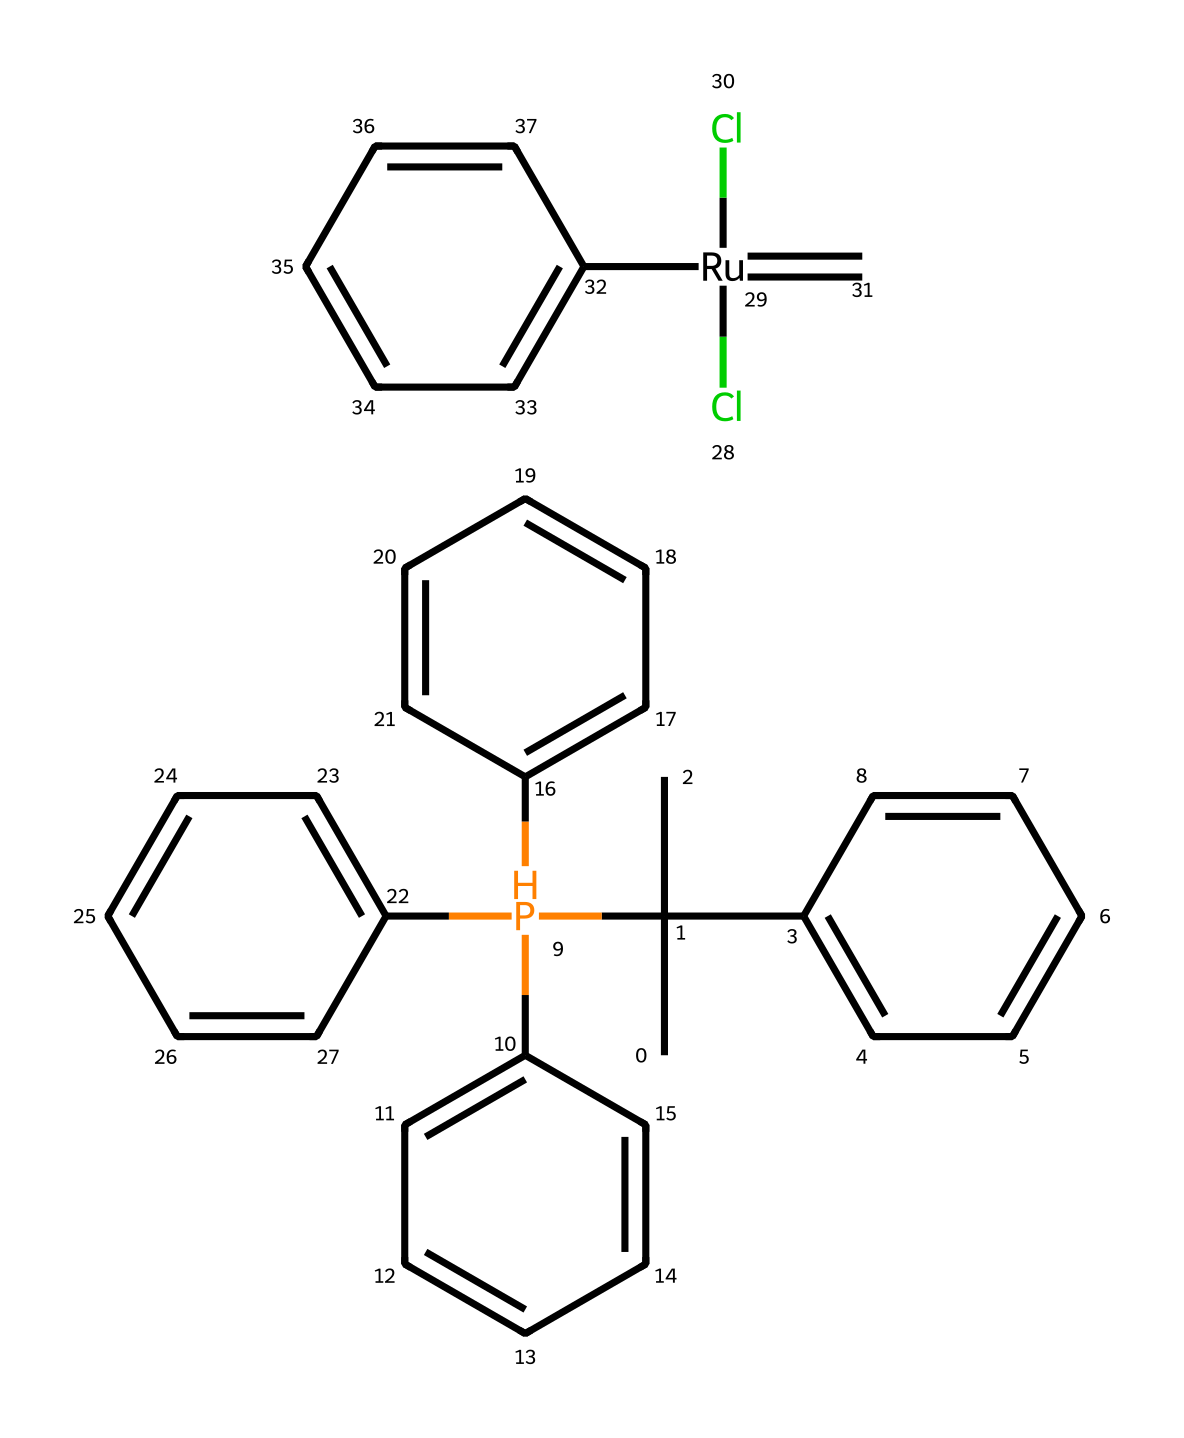What is the central metal in the Grubbs catalyst? The structure contains the element represented by "Ru," which refers to ruthenium, located at the center of the catalyst.
Answer: ruthenium How many aromatic rings are present in the Grubbs catalyst? By examining the structure, there are four distinct benzene rings indicated by the presence of multiple "C" atoms connected in a cyclic manner, showing the characteristic ring structure.
Answer: four What type of reaction is the Grubbs catalyst primarily used for? The Grubbs catalyst is known for catalyzing olefin metathesis reactions, which involves the exchange of alkene pairs.
Answer: olefin metathesis What is the charge of the ruthenium center in this catalyst? The "Cl[Ru](Cl)" portion indicates that the ruthenium is coordinated with chloride ions, which suggests it is in a neutral or +2 oxidation state, commonly found in this type of complex.
Answer: neutral How many chlorine atoms are attached to the ruthenium in this catalyst? Looking at the structure, there are two chloride ions indicated surrounding the ruthenium metal center.
Answer: two What functional groups are attached to the Grubbs catalyst? The catalyst features several phenyl groups and a phosphorus-containing moiety as indicated by the "P" symbol, identifying different functional groups linked to the organometallic framework.
Answer: phenyl and phosphorus What role does phosphorus play in the structure of the Grubbs catalyst? The phosphorus atom serves as a stabilizing ligand, coordinating with the metal center and influencing the reactivity profile of the catalyst during reactions.
Answer: stabilizing ligand 